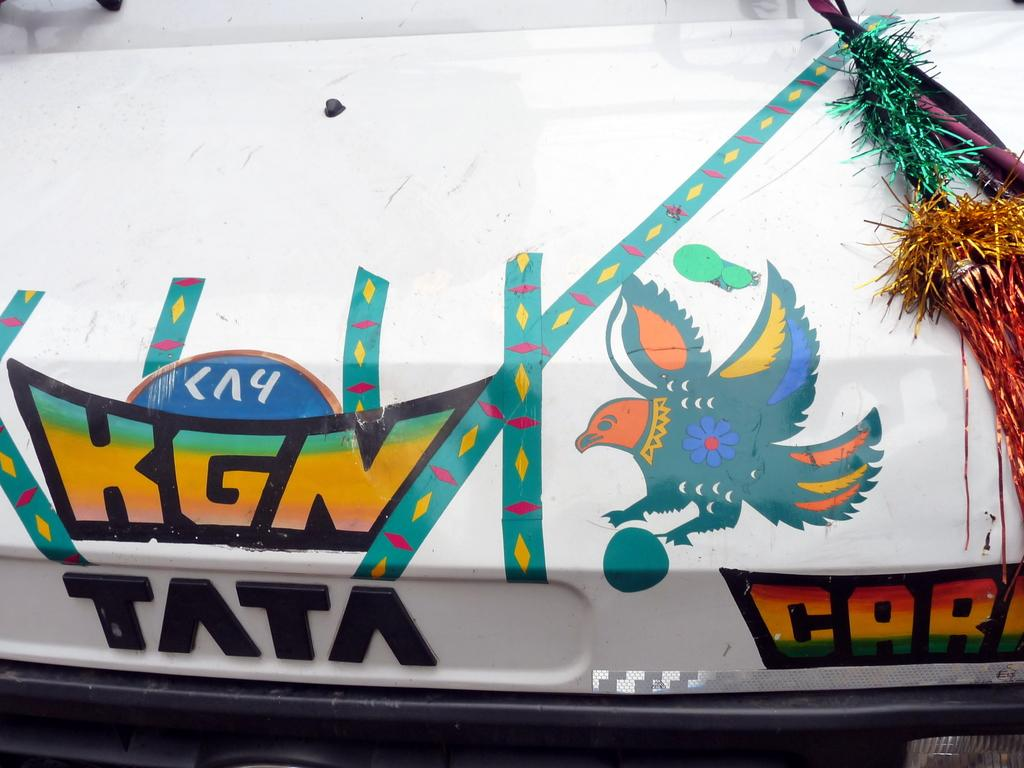What type of object is featured in the image? There is a part of a vehicle in the image. What can be seen on the vehicle part? The vehicle part has text and an image on it. Are there any additional decorative elements associated with the vehicle in the image? Yes, there are decorative objects associated with the vehicle in the image. What type of cork can be seen in the image? There is no cork present in the image. Is the vehicle part being used as a suit in the image? The vehicle part is not being used as a suit in the image; it is a part of a vehicle with text and an image on it. 